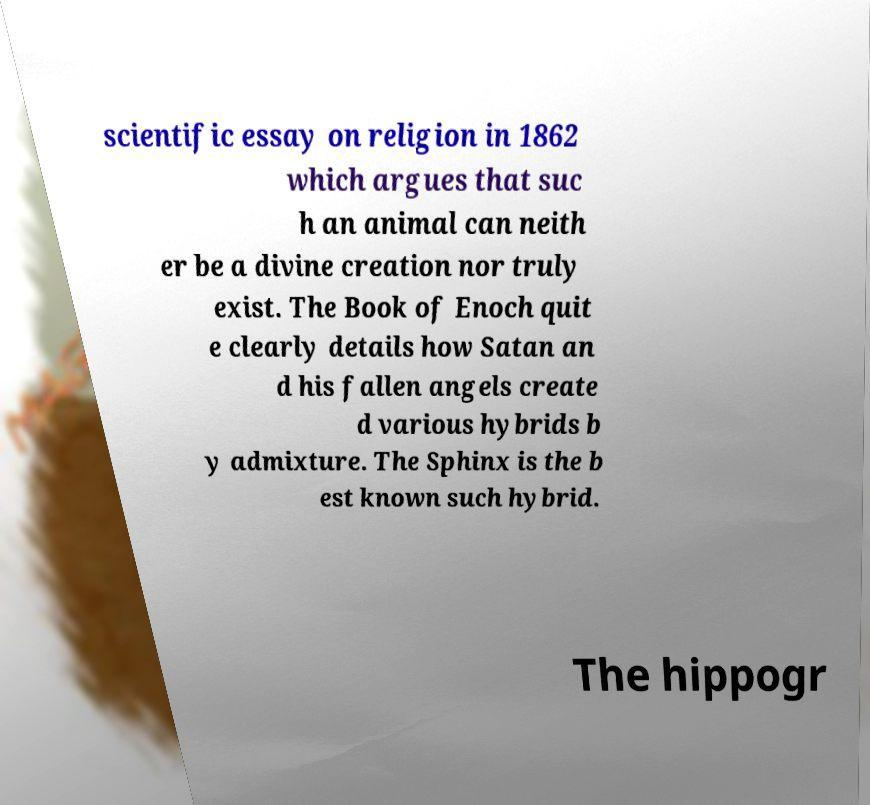I need the written content from this picture converted into text. Can you do that? scientific essay on religion in 1862 which argues that suc h an animal can neith er be a divine creation nor truly exist. The Book of Enoch quit e clearly details how Satan an d his fallen angels create d various hybrids b y admixture. The Sphinx is the b est known such hybrid. The hippogr 